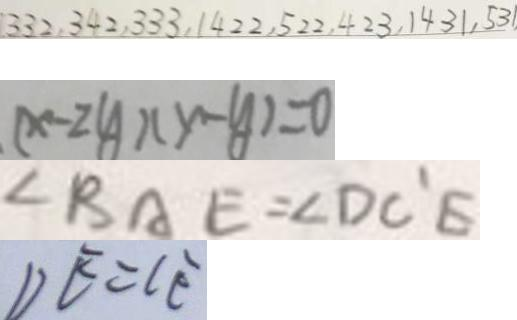<formula> <loc_0><loc_0><loc_500><loc_500>3 3 2 , 3 4 2 , 3 3 3 , 1 4 2 2 , 5 2 2 , 4 2 3 , 1 4 3 1 , 5 3 1 
 ( x - 2 y ) ( x - y ) = 0 
 \angle B A E = \angle D C ^ { \prime } E 
 D E = C E</formula> 